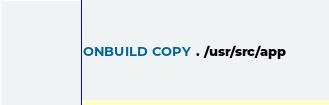Convert code to text. <code><loc_0><loc_0><loc_500><loc_500><_Dockerfile_>
ONBUILD COPY . /usr/src/app
</code> 